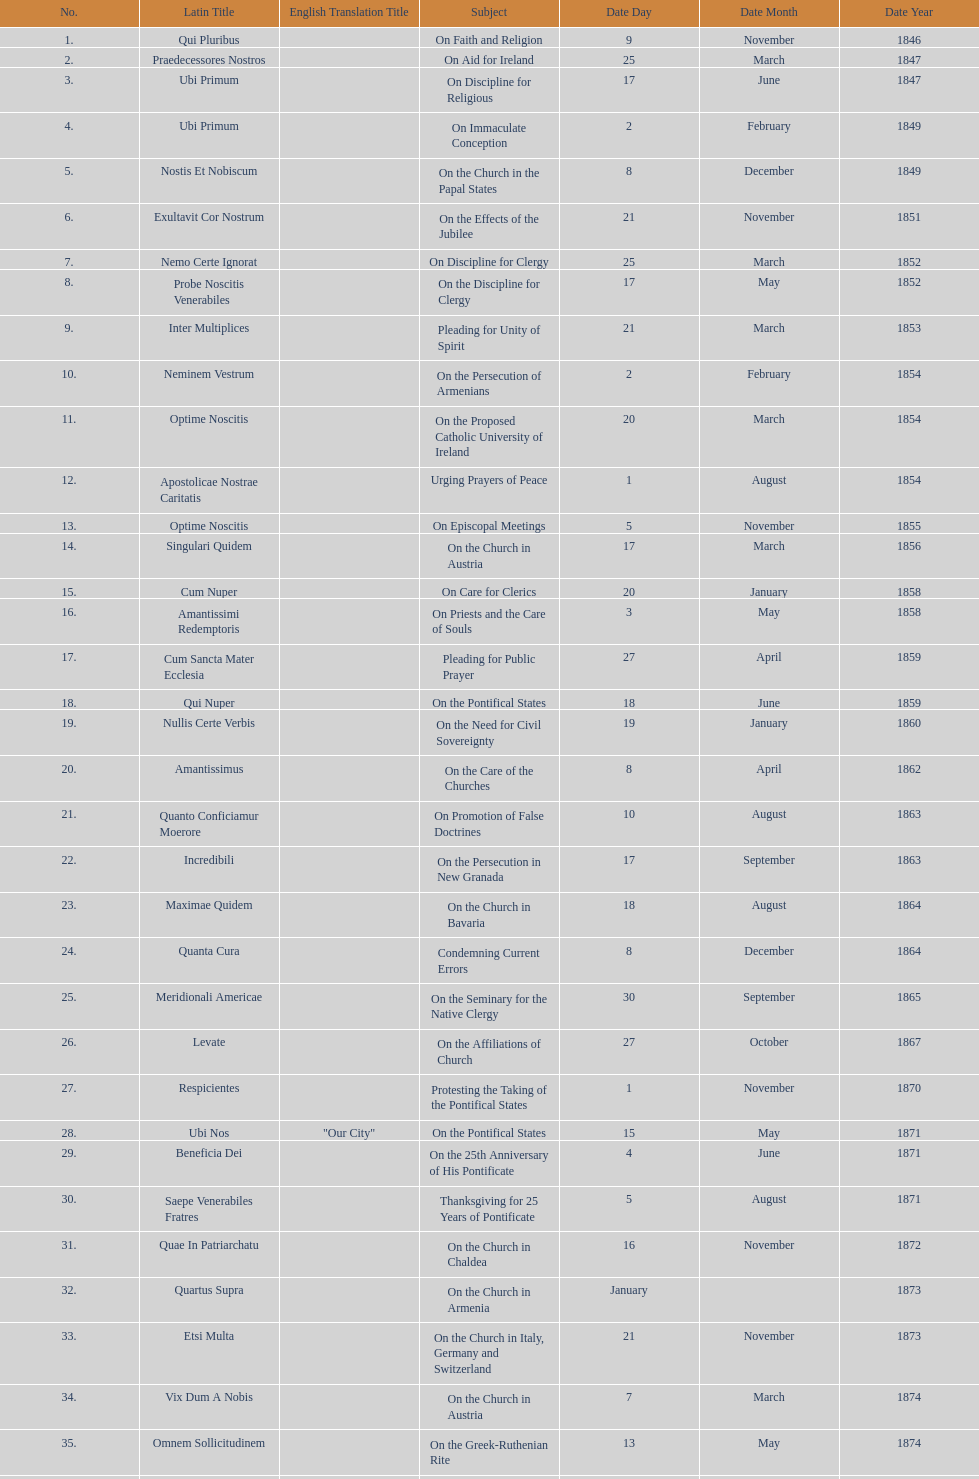Give me the full table as a dictionary. {'header': ['No.', 'Latin Title', 'English Translation Title', 'Subject', 'Date Day', 'Date Month', 'Date Year'], 'rows': [['1.', 'Qui Pluribus', '', 'On Faith and Religion', '9', 'November', '1846'], ['2.', 'Praedecessores Nostros', '', 'On Aid for Ireland', '25', 'March', '1847'], ['3.', 'Ubi Primum', '', 'On Discipline for Religious', '17', 'June', '1847'], ['4.', 'Ubi Primum', '', 'On Immaculate Conception', '2', 'February', '1849'], ['5.', 'Nostis Et Nobiscum', '', 'On the Church in the Papal States', '8', 'December', '1849'], ['6.', 'Exultavit Cor Nostrum', '', 'On the Effects of the Jubilee', '21', 'November', '1851'], ['7.', 'Nemo Certe Ignorat', '', 'On Discipline for Clergy', '25', 'March', '1852'], ['8.', 'Probe Noscitis Venerabiles', '', 'On the Discipline for Clergy', '17', 'May', '1852'], ['9.', 'Inter Multiplices', '', 'Pleading for Unity of Spirit', '21', 'March', '1853'], ['10.', 'Neminem Vestrum', '', 'On the Persecution of Armenians', '2', 'February', '1854'], ['11.', 'Optime Noscitis', '', 'On the Proposed Catholic University of Ireland', '20', 'March', '1854'], ['12.', 'Apostolicae Nostrae Caritatis', '', 'Urging Prayers of Peace', '1', 'August', '1854'], ['13.', 'Optime Noscitis', '', 'On Episcopal Meetings', '5', 'November', '1855'], ['14.', 'Singulari Quidem', '', 'On the Church in Austria', '17', 'March', '1856'], ['15.', 'Cum Nuper', '', 'On Care for Clerics', '20', 'January', '1858'], ['16.', 'Amantissimi Redemptoris', '', 'On Priests and the Care of Souls', '3', 'May', '1858'], ['17.', 'Cum Sancta Mater Ecclesia', '', 'Pleading for Public Prayer', '27', 'April', '1859'], ['18.', 'Qui Nuper', '', 'On the Pontifical States', '18', 'June', '1859'], ['19.', 'Nullis Certe Verbis', '', 'On the Need for Civil Sovereignty', '19', 'January', '1860'], ['20.', 'Amantissimus', '', 'On the Care of the Churches', '8', 'April', '1862'], ['21.', 'Quanto Conficiamur Moerore', '', 'On Promotion of False Doctrines', '10', 'August', '1863'], ['22.', 'Incredibili', '', 'On the Persecution in New Granada', '17', 'September', '1863'], ['23.', 'Maximae Quidem', '', 'On the Church in Bavaria', '18', 'August', '1864'], ['24.', 'Quanta Cura', '', 'Condemning Current Errors', '8', 'December', '1864'], ['25.', 'Meridionali Americae', '', 'On the Seminary for the Native Clergy', '30', 'September', '1865'], ['26.', 'Levate', '', 'On the Affiliations of Church', '27', 'October', '1867'], ['27.', 'Respicientes', '', 'Protesting the Taking of the Pontifical States', '1', 'November', '1870'], ['28.', 'Ubi Nos', '"Our City"', 'On the Pontifical States', '15', 'May', '1871'], ['29.', 'Beneficia Dei', '', 'On the 25th Anniversary of His Pontificate', '4', 'June', '1871'], ['30.', 'Saepe Venerabiles Fratres', '', 'Thanksgiving for 25 Years of Pontificate', '5', 'August', '1871'], ['31.', 'Quae In Patriarchatu', '', 'On the Church in Chaldea', '16', 'November', '1872'], ['32.', 'Quartus Supra', '', 'On the Church in Armenia', 'January', '', '1873'], ['33.', 'Etsi Multa', '', 'On the Church in Italy, Germany and Switzerland', '21', 'November', '1873'], ['34.', 'Vix Dum A Nobis', '', 'On the Church in Austria', '7', 'March', '1874'], ['35.', 'Omnem Sollicitudinem', '', 'On the Greek-Ruthenian Rite', '13', 'May', '1874'], ['36.', 'Gravibus Ecclesiae', '', 'Proclaiming A Jubilee', '24', 'December', '1874'], ['37.', 'Quod Nunquam', '', 'On the Church in Prussia', '5', 'February', '1875'], ['38.', 'Graves Ac Diuturnae', '', 'On the Church in Switzerland', '23', 'March', '1875']]} What is the total number of title? 38. 